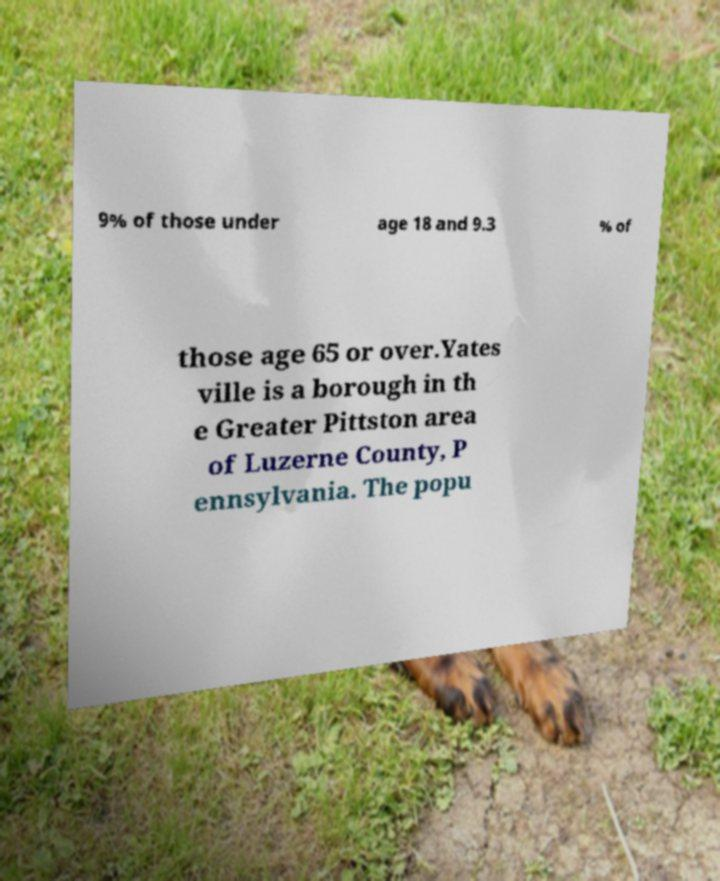Can you accurately transcribe the text from the provided image for me? 9% of those under age 18 and 9.3 % of those age 65 or over.Yates ville is a borough in th e Greater Pittston area of Luzerne County, P ennsylvania. The popu 